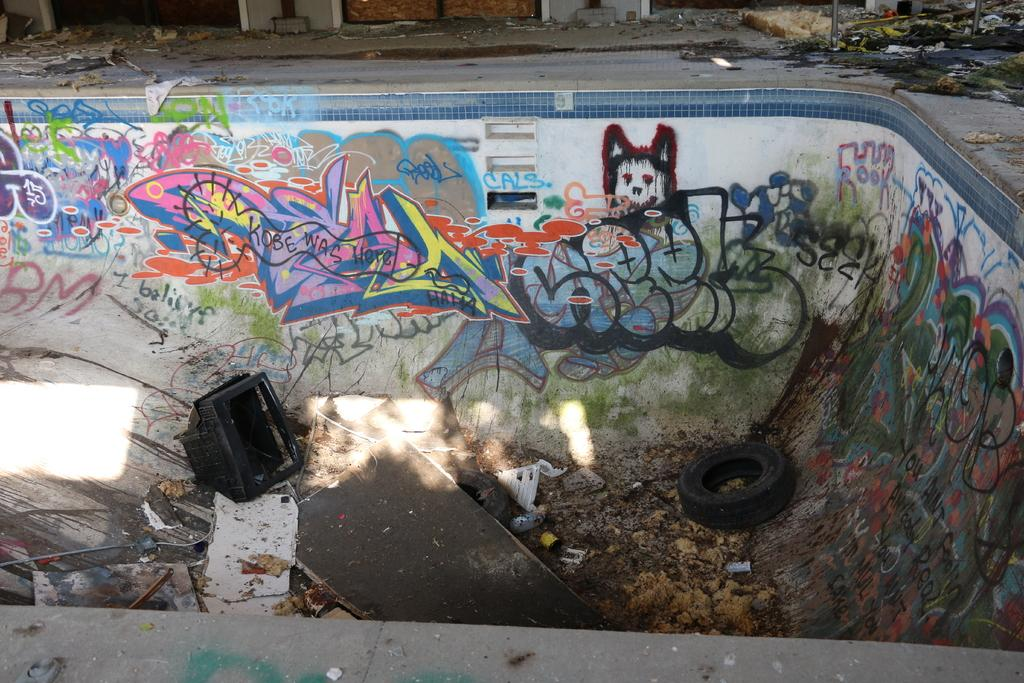What can be found on the platform in the image? There are drawings and texts, a tire, wooden objects, a TV, and waste on the platform. What type of object is the tire in the image? The tire is a round object typically used on vehicles. What material are the wooden objects made of? The wooden objects are made of wood. What electronic device is present on the platform? There is a TV on the platform. What type of fowl can be seen interacting with the wooden objects on the platform? There is no fowl present in the image; it only features drawings, texts, a tire, wooden objects, a TV, and waste on the platform. What kind of bead is used to decorate the tire in the image? There are no beads present in the image, and the tire is not decorated. 